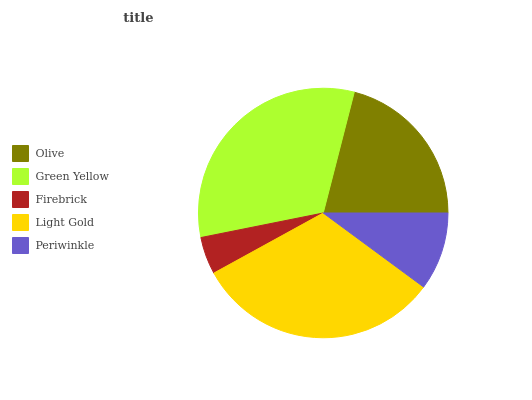Is Firebrick the minimum?
Answer yes or no. Yes. Is Green Yellow the maximum?
Answer yes or no. Yes. Is Green Yellow the minimum?
Answer yes or no. No. Is Firebrick the maximum?
Answer yes or no. No. Is Green Yellow greater than Firebrick?
Answer yes or no. Yes. Is Firebrick less than Green Yellow?
Answer yes or no. Yes. Is Firebrick greater than Green Yellow?
Answer yes or no. No. Is Green Yellow less than Firebrick?
Answer yes or no. No. Is Olive the high median?
Answer yes or no. Yes. Is Olive the low median?
Answer yes or no. Yes. Is Periwinkle the high median?
Answer yes or no. No. Is Light Gold the low median?
Answer yes or no. No. 